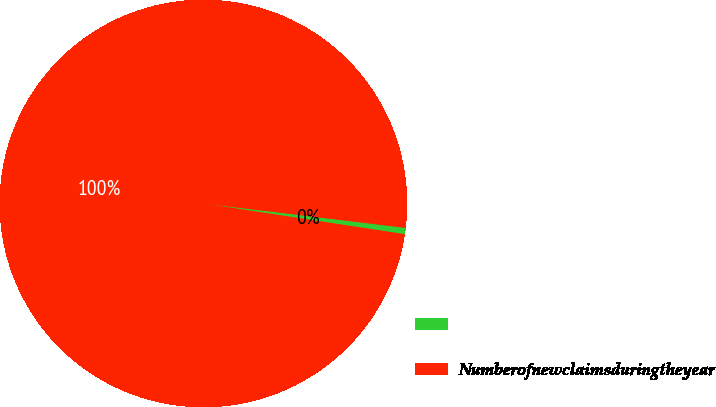<chart> <loc_0><loc_0><loc_500><loc_500><pie_chart><ecel><fcel>Numberofnewclaimsduringtheyear<nl><fcel>0.5%<fcel>99.5%<nl></chart> 